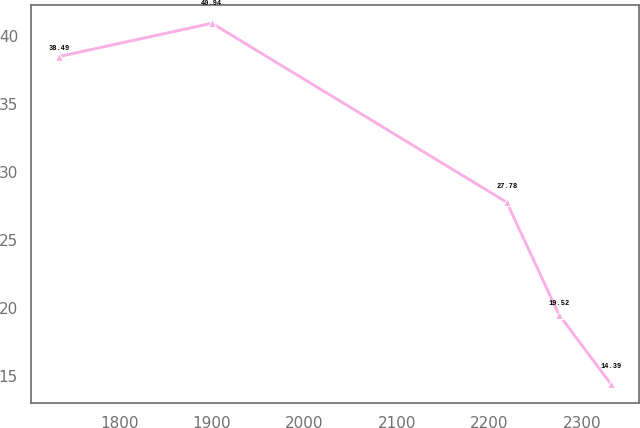Convert chart to OTSL. <chart><loc_0><loc_0><loc_500><loc_500><line_chart><ecel><fcel>Unnamed: 1<nl><fcel>1734.93<fcel>38.49<nl><fcel>1900.28<fcel>40.94<nl><fcel>2218.65<fcel>27.78<nl><fcel>2275.03<fcel>19.52<nl><fcel>2331.41<fcel>14.39<nl></chart> 